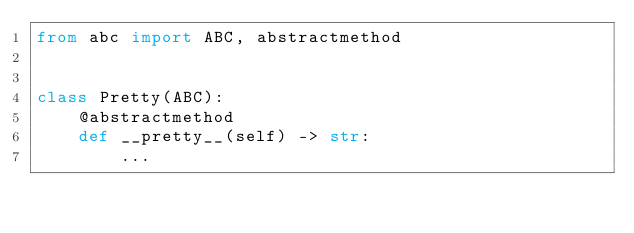Convert code to text. <code><loc_0><loc_0><loc_500><loc_500><_Python_>from abc import ABC, abstractmethod


class Pretty(ABC):
    @abstractmethod
    def __pretty__(self) -> str:
        ...
</code> 